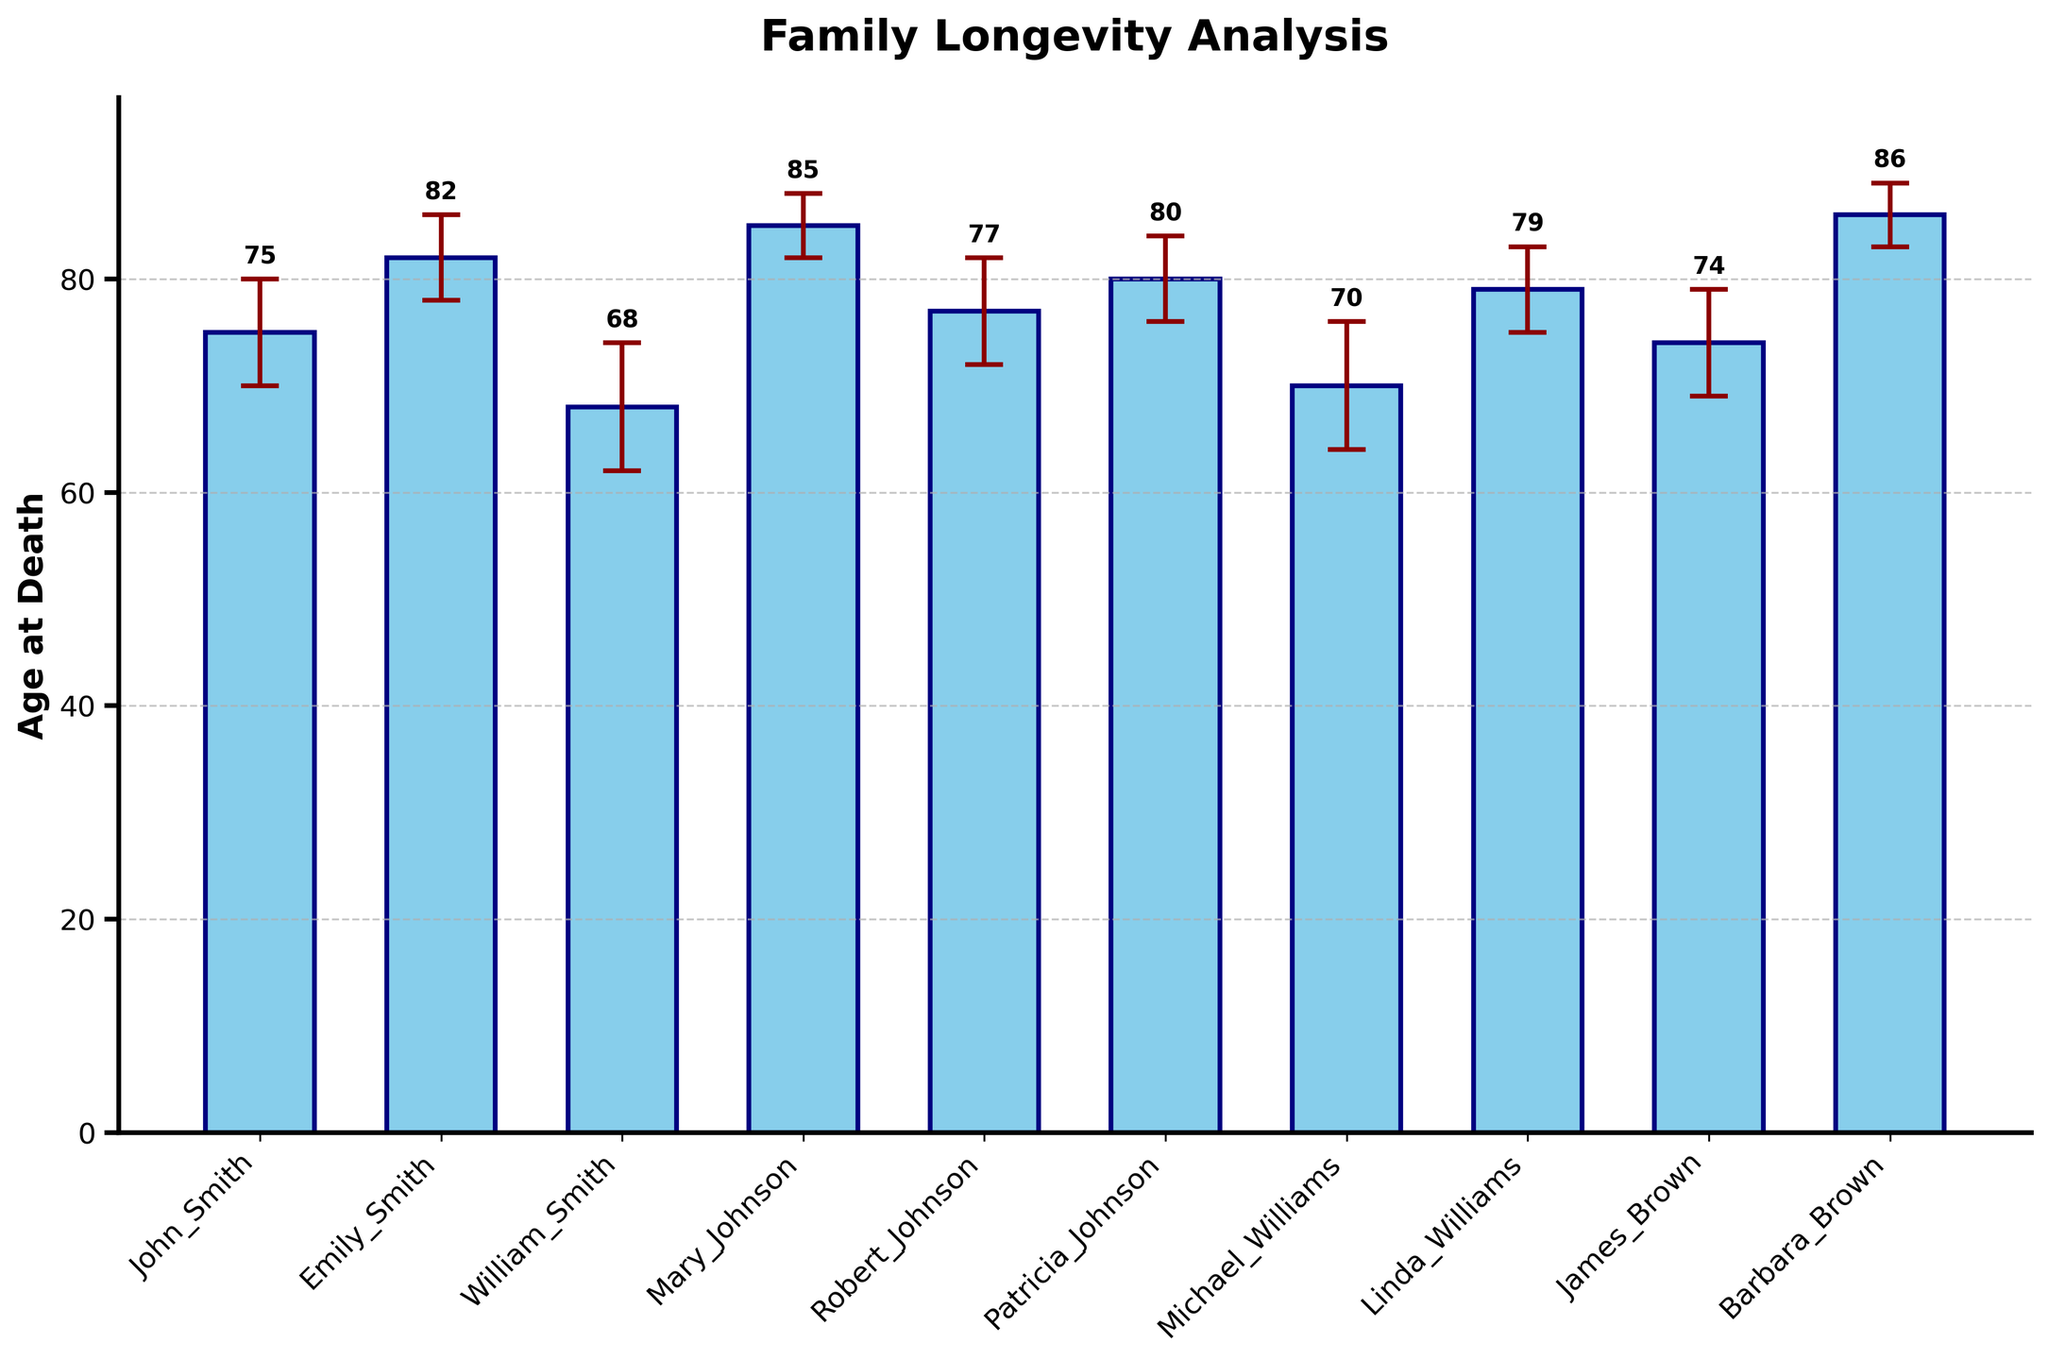Which family member lived the longest? The family member with the highest bar indicates the longest lifespan. In this case, Mary Johnson and Barbara Brown have the tallest bars.
Answer: Mary Johnson and Barbara Brown What is the title of the chart? The title is displayed at the top of the chart.
Answer: Family Longevity Analysis Which family member had the lowest standard deviation in age at death? The smallest error bar corresponds to the smallest standard deviation. Both Mary Johnson and Barbara Brown have the smallest error bars.
Answer: Mary Johnson and Barbara Brown What is the average age at death for the family members? Sum all ages and divide by the number of family members: (75 + 82 + 68 + 85 + 77 + 80 + 70 + 79 + 74 + 86) / 10 = 776 / 10 = 77.6
Answer: 77.6 How does Patricia Johnson's age at death compare with Michael Williams's age at death? Michael Williams lived 70 years and Patricia Johnson lived 80 years, so Patricia lived longer.
Answer: Patricia Johnson lived longer What is the range of ages at death depicted in the chart? The range is the difference between the maximum and minimum ages. Maximum age: 86 (Barbara Brown), Minimum age: 68 (William Smith). Range: 86 - 68 = 18.
Answer: 18 How many family members lived to be at least 80 years old? Identify bars that are at least at the 80 mark. There are 5 such bars: Emily Smith, Mary Johnson, Patricia Johnson, Linda Williams, and Barbara Brown.
Answer: 5 Which family member had the highest standard deviation in age at death? The largest error bar corresponds to the highest standard deviation, which is William Smith with a standard deviation of 6 years.
Answer: William Smith What is the total sum of the standard deviations presented in the chart? Add up all the standard deviations: 5 + 4 + 6 + 3 + 5 + 4 + 6 + 4 + 5 + 3 = 45.
Answer: 45 Who lived longer on average, the Smith family or the Johnson family members? Calculate the average for each group: Smiths (John: 75, Emily: 82, William: 68) = (75 + 82 + 68) / 3 = 75; Johnsons (Mary: 85, Robert: 77, Patricia: 80) = (85 + 77 + 80) / 3 = 80.7. The Johnson family has a higher average.
Answer: The Johnson family 